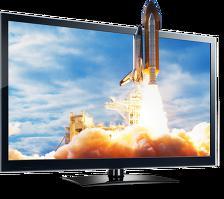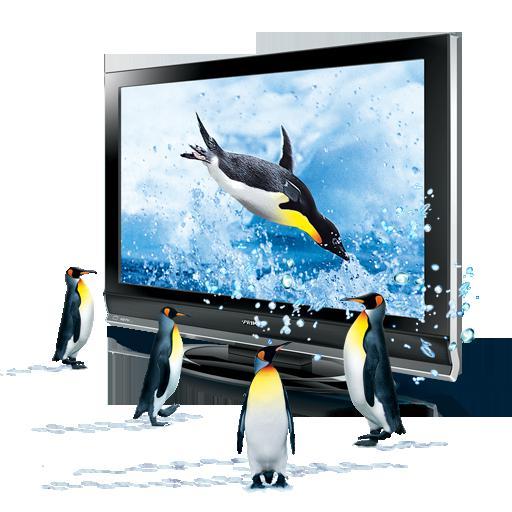The first image is the image on the left, the second image is the image on the right. Evaluate the accuracy of this statement regarding the images: "There is a vehicle flying in the air on the screen of one of the monitors.". Is it true? Answer yes or no. Yes. The first image is the image on the left, the second image is the image on the right. Examine the images to the left and right. Is the description "One of the TVs shows a type of aircraft on the screen, with part of the vehicle extending off the screen." accurate? Answer yes or no. Yes. 